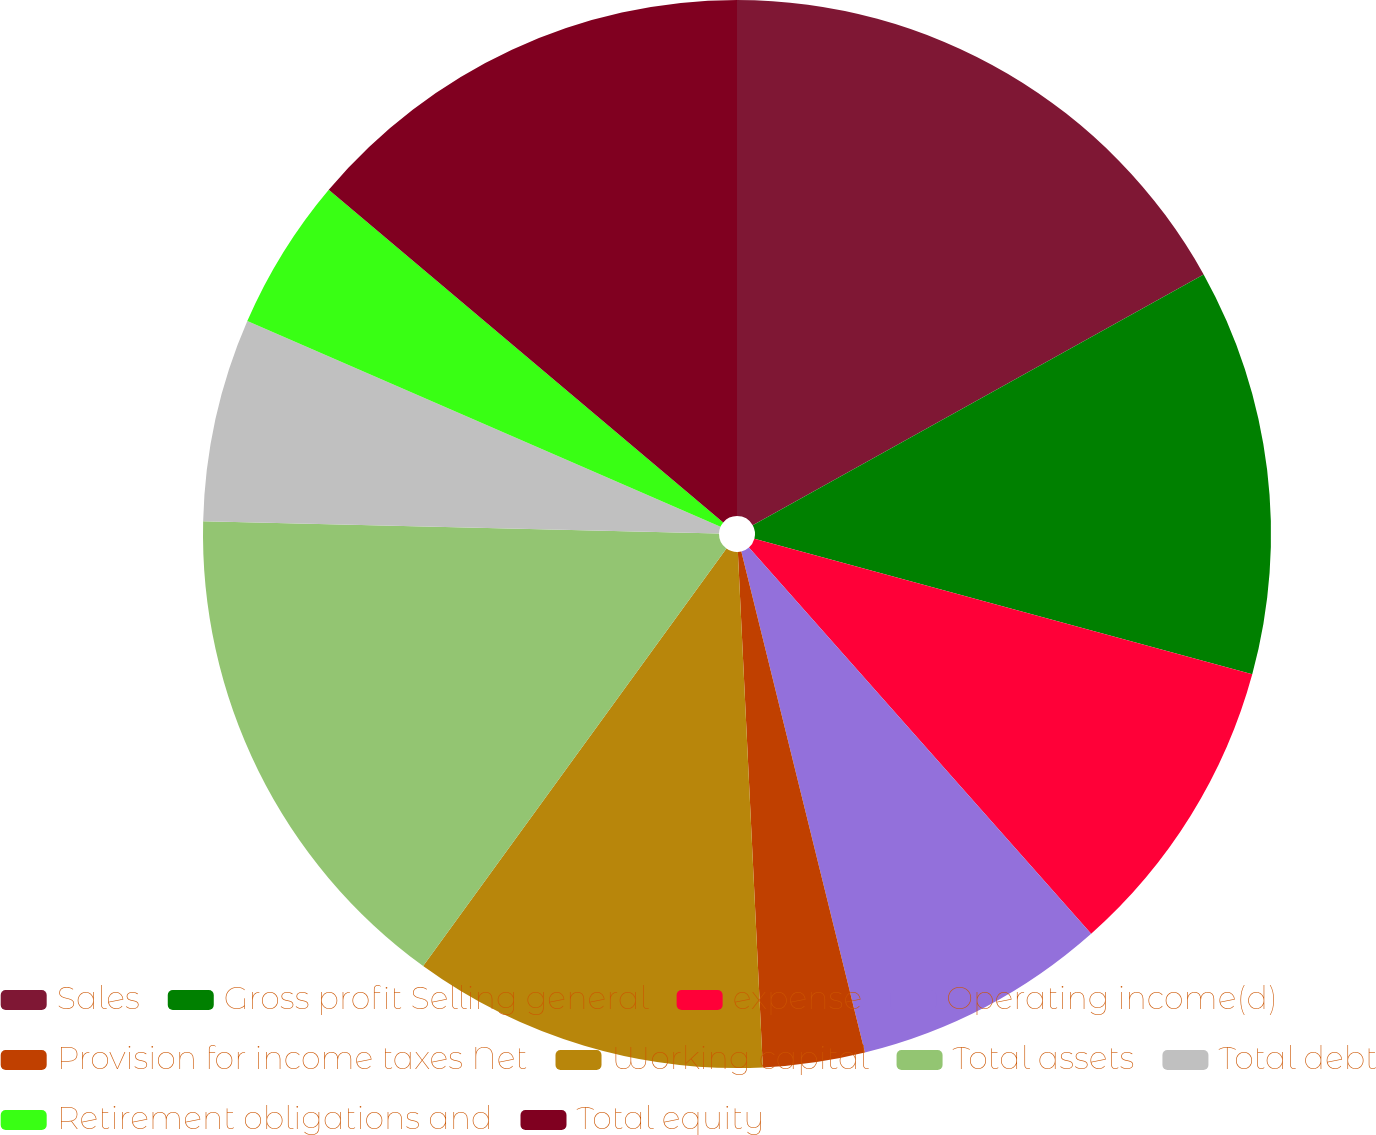Convert chart. <chart><loc_0><loc_0><loc_500><loc_500><pie_chart><fcel>Sales<fcel>Gross profit Selling general<fcel>expense<fcel>Operating income(d)<fcel>Provision for income taxes Net<fcel>Working capital<fcel>Total assets<fcel>Total debt<fcel>Retirement obligations and<fcel>Total equity<nl><fcel>16.92%<fcel>12.31%<fcel>9.23%<fcel>7.69%<fcel>3.08%<fcel>10.77%<fcel>15.38%<fcel>6.15%<fcel>4.62%<fcel>13.85%<nl></chart> 